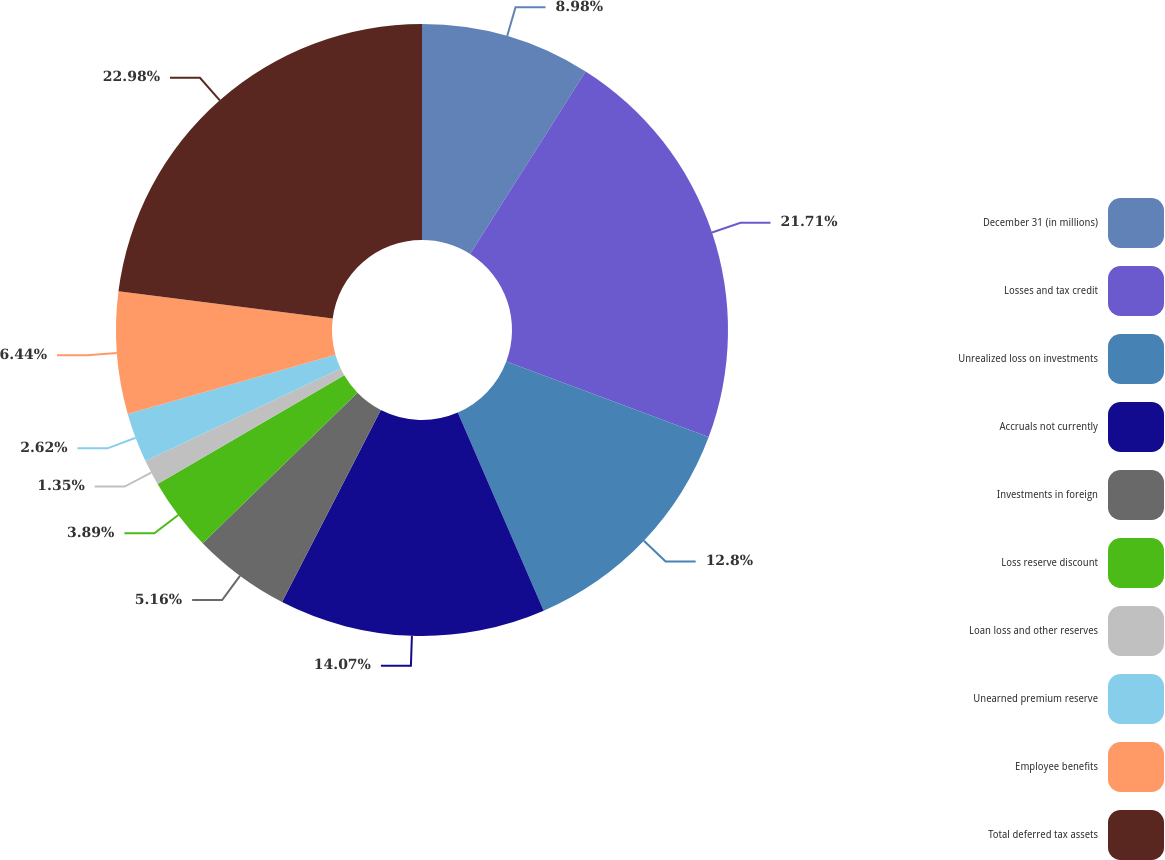<chart> <loc_0><loc_0><loc_500><loc_500><pie_chart><fcel>December 31 (in millions)<fcel>Losses and tax credit<fcel>Unrealized loss on investments<fcel>Accruals not currently<fcel>Investments in foreign<fcel>Loss reserve discount<fcel>Loan loss and other reserves<fcel>Unearned premium reserve<fcel>Employee benefits<fcel>Total deferred tax assets<nl><fcel>8.98%<fcel>21.71%<fcel>12.8%<fcel>14.07%<fcel>5.16%<fcel>3.89%<fcel>1.35%<fcel>2.62%<fcel>6.44%<fcel>22.98%<nl></chart> 